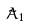<formula> <loc_0><loc_0><loc_500><loc_500>\tilde { A } _ { 1 }</formula> 